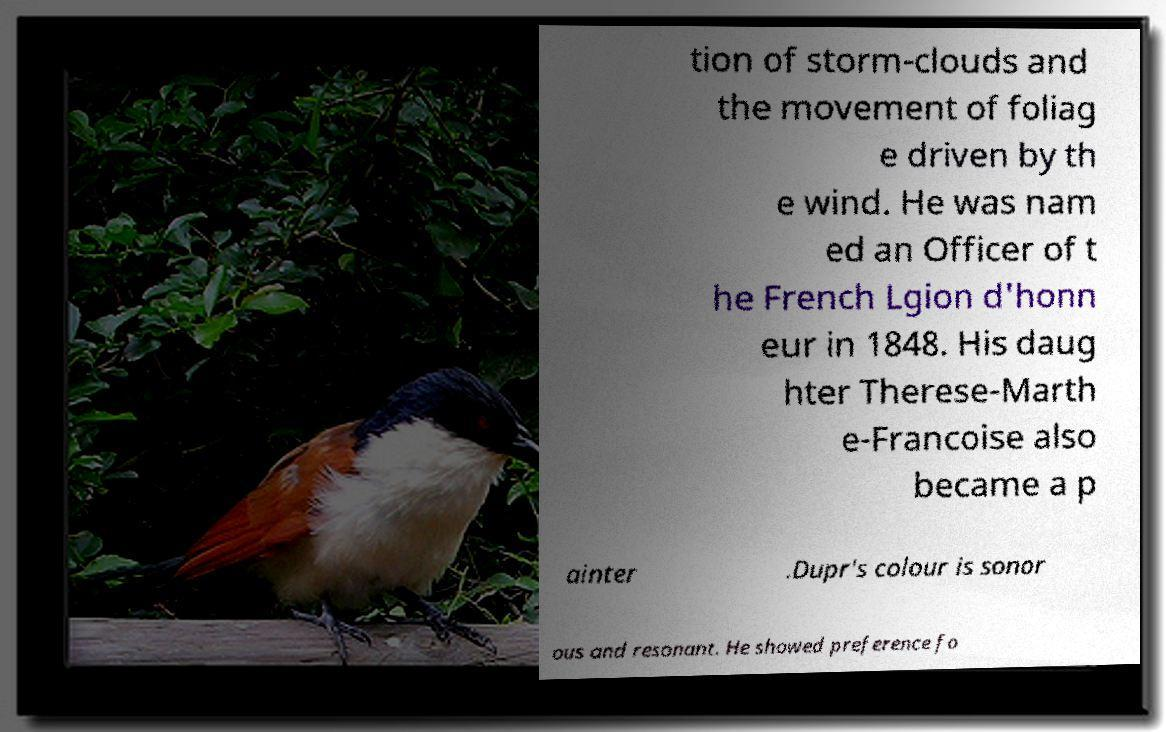Please read and relay the text visible in this image. What does it say? tion of storm-clouds and the movement of foliag e driven by th e wind. He was nam ed an Officer of t he French Lgion d'honn eur in 1848. His daug hter Therese-Marth e-Francoise also became a p ainter .Dupr's colour is sonor ous and resonant. He showed preference fo 